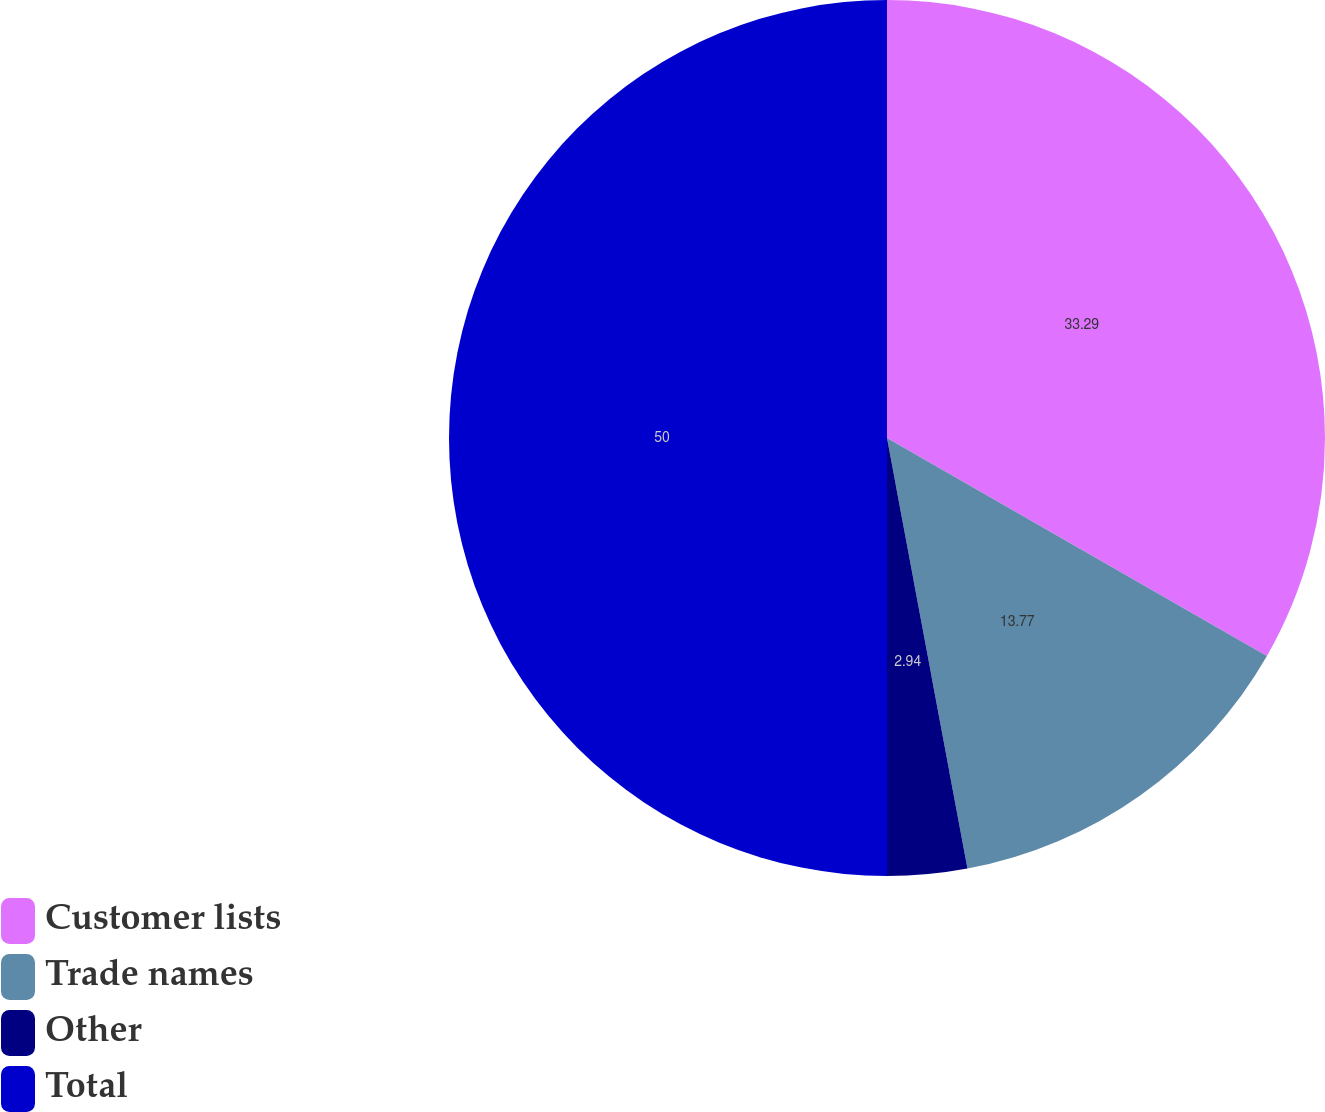Convert chart to OTSL. <chart><loc_0><loc_0><loc_500><loc_500><pie_chart><fcel>Customer lists<fcel>Trade names<fcel>Other<fcel>Total<nl><fcel>33.29%<fcel>13.77%<fcel>2.94%<fcel>50.0%<nl></chart> 